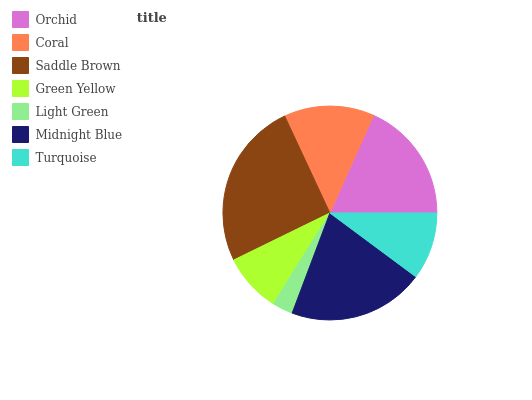Is Light Green the minimum?
Answer yes or no. Yes. Is Saddle Brown the maximum?
Answer yes or no. Yes. Is Coral the minimum?
Answer yes or no. No. Is Coral the maximum?
Answer yes or no. No. Is Orchid greater than Coral?
Answer yes or no. Yes. Is Coral less than Orchid?
Answer yes or no. Yes. Is Coral greater than Orchid?
Answer yes or no. No. Is Orchid less than Coral?
Answer yes or no. No. Is Coral the high median?
Answer yes or no. Yes. Is Coral the low median?
Answer yes or no. Yes. Is Light Green the high median?
Answer yes or no. No. Is Midnight Blue the low median?
Answer yes or no. No. 